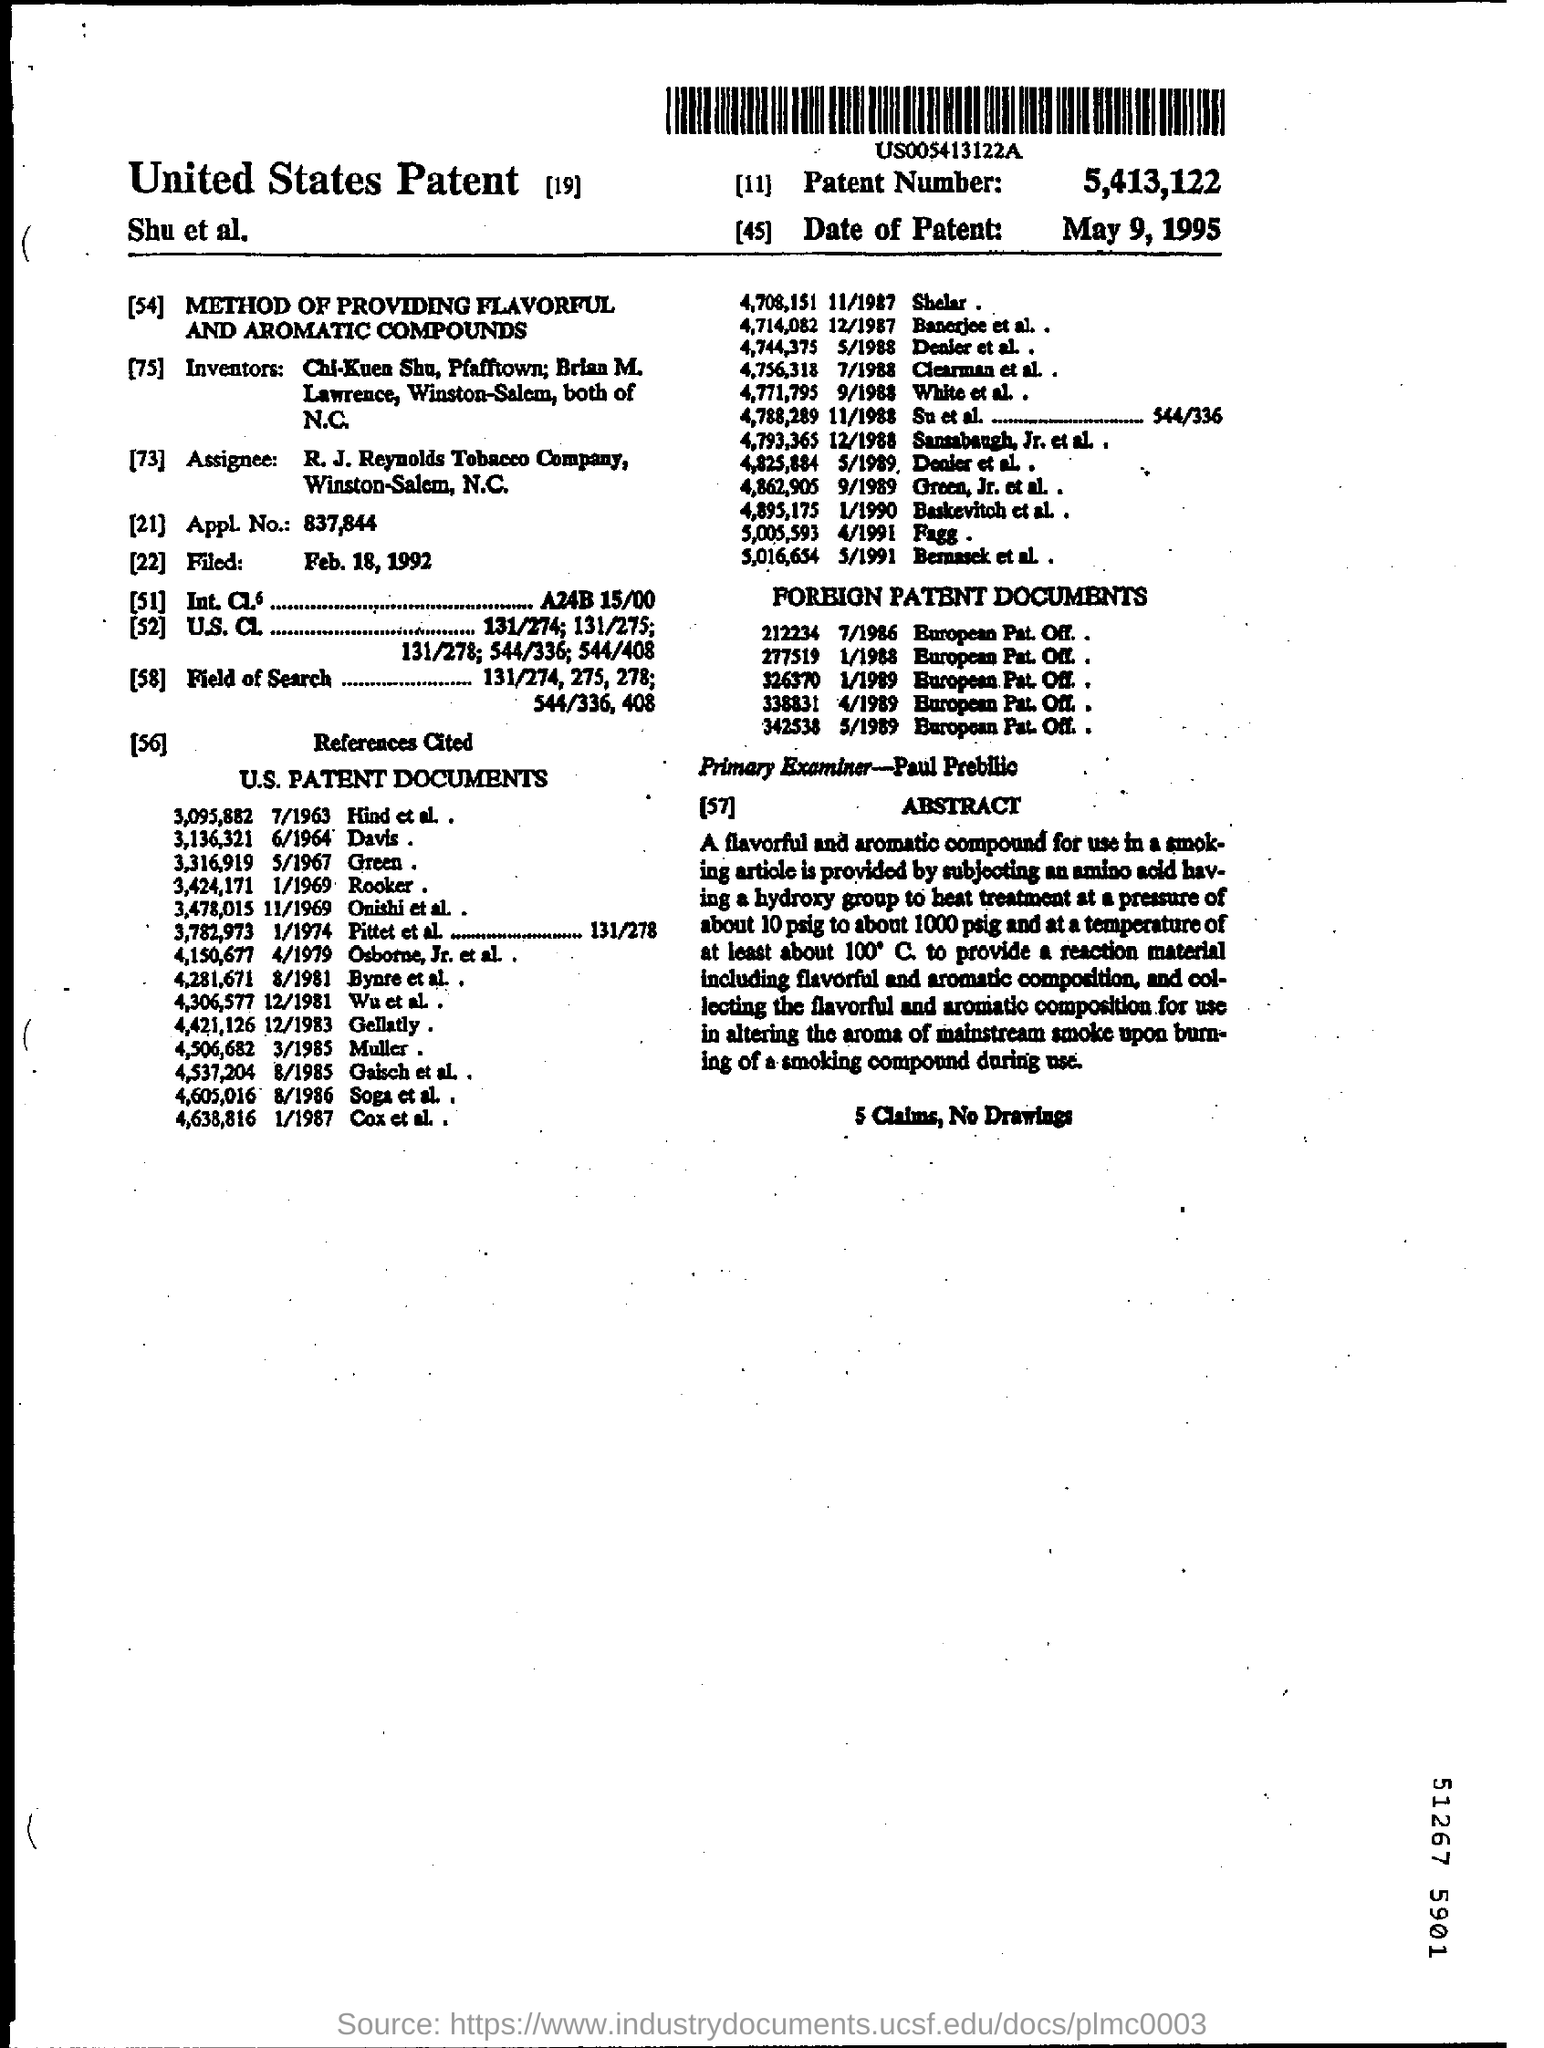Specify some key components in this picture. The patent application number is 837,844. The patent number is 5,413,122. The application was filed on February 18, 1992. The R.J. Reynolds Tobacco Company is the assignee. The date of the patent is May 9, 1995. 